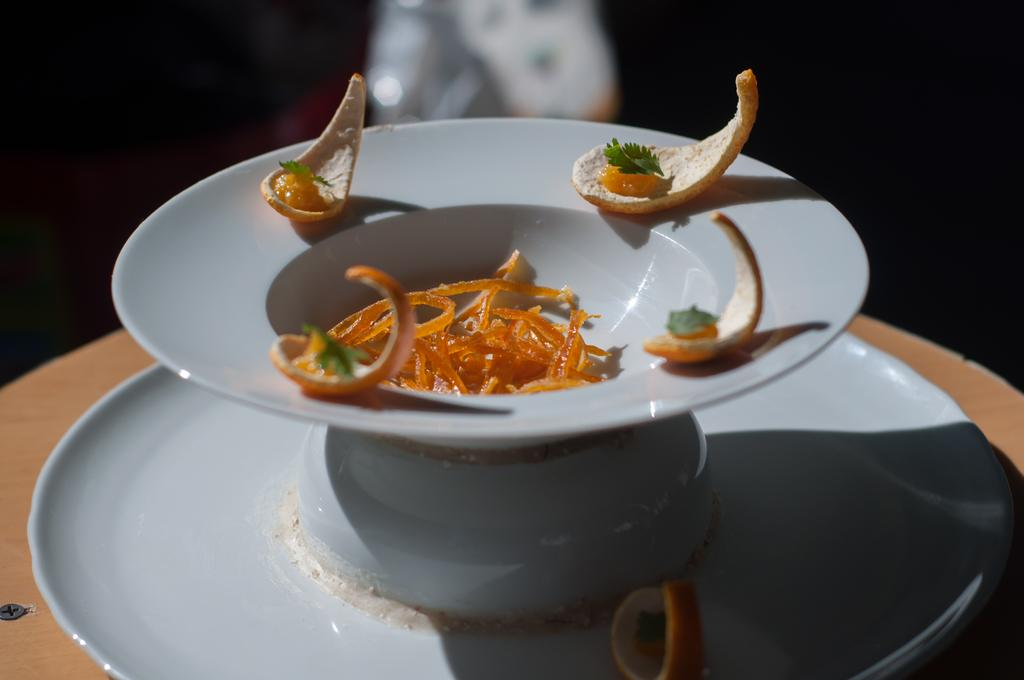What type of food contains the peel of an orange in the image? The food containing the peel of an orange is not specified in the image. How is the food presented in the image? The food is placed on a plate in the image. Where is the plate located in the image? The plate is placed on a table in the image. What type of garden can be seen in the image? There is no garden present in the image. What invention is being used to prepare the food in the image? The facts provided do not mention any specific invention used to prepare the food. 